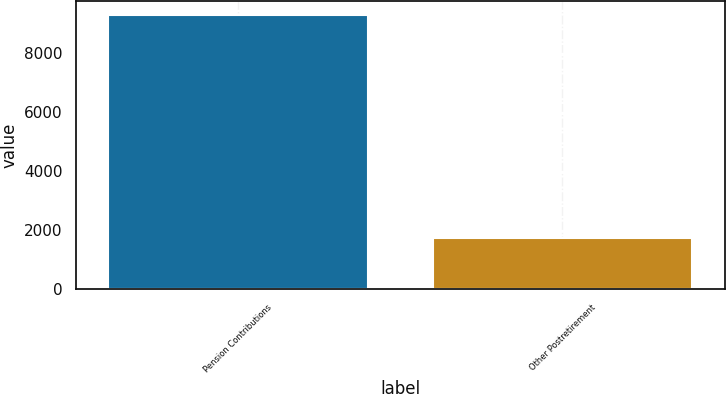<chart> <loc_0><loc_0><loc_500><loc_500><bar_chart><fcel>Pension Contributions<fcel>Other Postretirement<nl><fcel>9266<fcel>1732<nl></chart> 